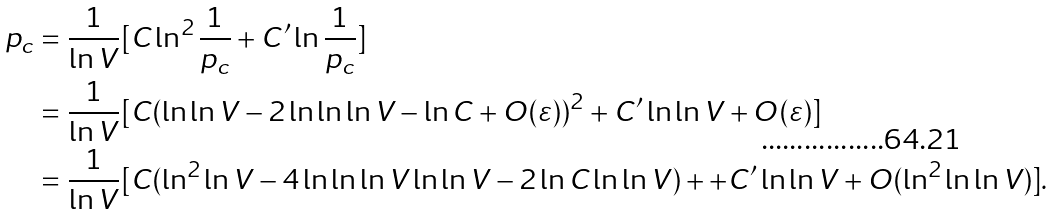<formula> <loc_0><loc_0><loc_500><loc_500>p _ { c } & = \frac { 1 } { \ln V } [ C \ln ^ { 2 } \frac { 1 } { p _ { c } } + C ^ { \prime } \ln \frac { 1 } { p _ { c } } ] \\ & = \frac { 1 } { \ln V } [ C ( \ln \ln V - 2 \ln \ln \ln V - \ln C + O ( \varepsilon ) ) ^ { 2 } + C ^ { \prime } \ln \ln V + O ( \varepsilon ) ] \\ & = \frac { 1 } { \ln V } [ C ( \ln ^ { 2 } \ln V - 4 \ln \ln \ln V \ln \ln V - 2 \ln C \ln \ln V ) + + C ^ { \prime } \ln \ln V + O ( \ln ^ { 2 } \ln \ln V ) ] .</formula> 